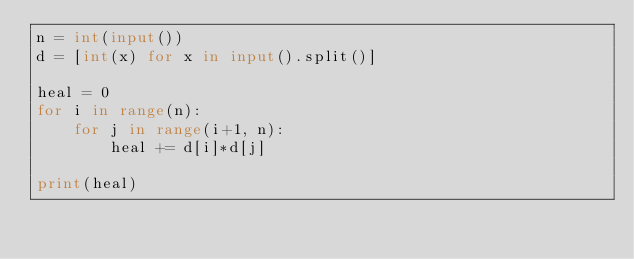Convert code to text. <code><loc_0><loc_0><loc_500><loc_500><_Python_>n = int(input())
d = [int(x) for x in input().split()]

heal = 0
for i in range(n):
    for j in range(i+1, n):
        heal += d[i]*d[j]

print(heal)
</code> 